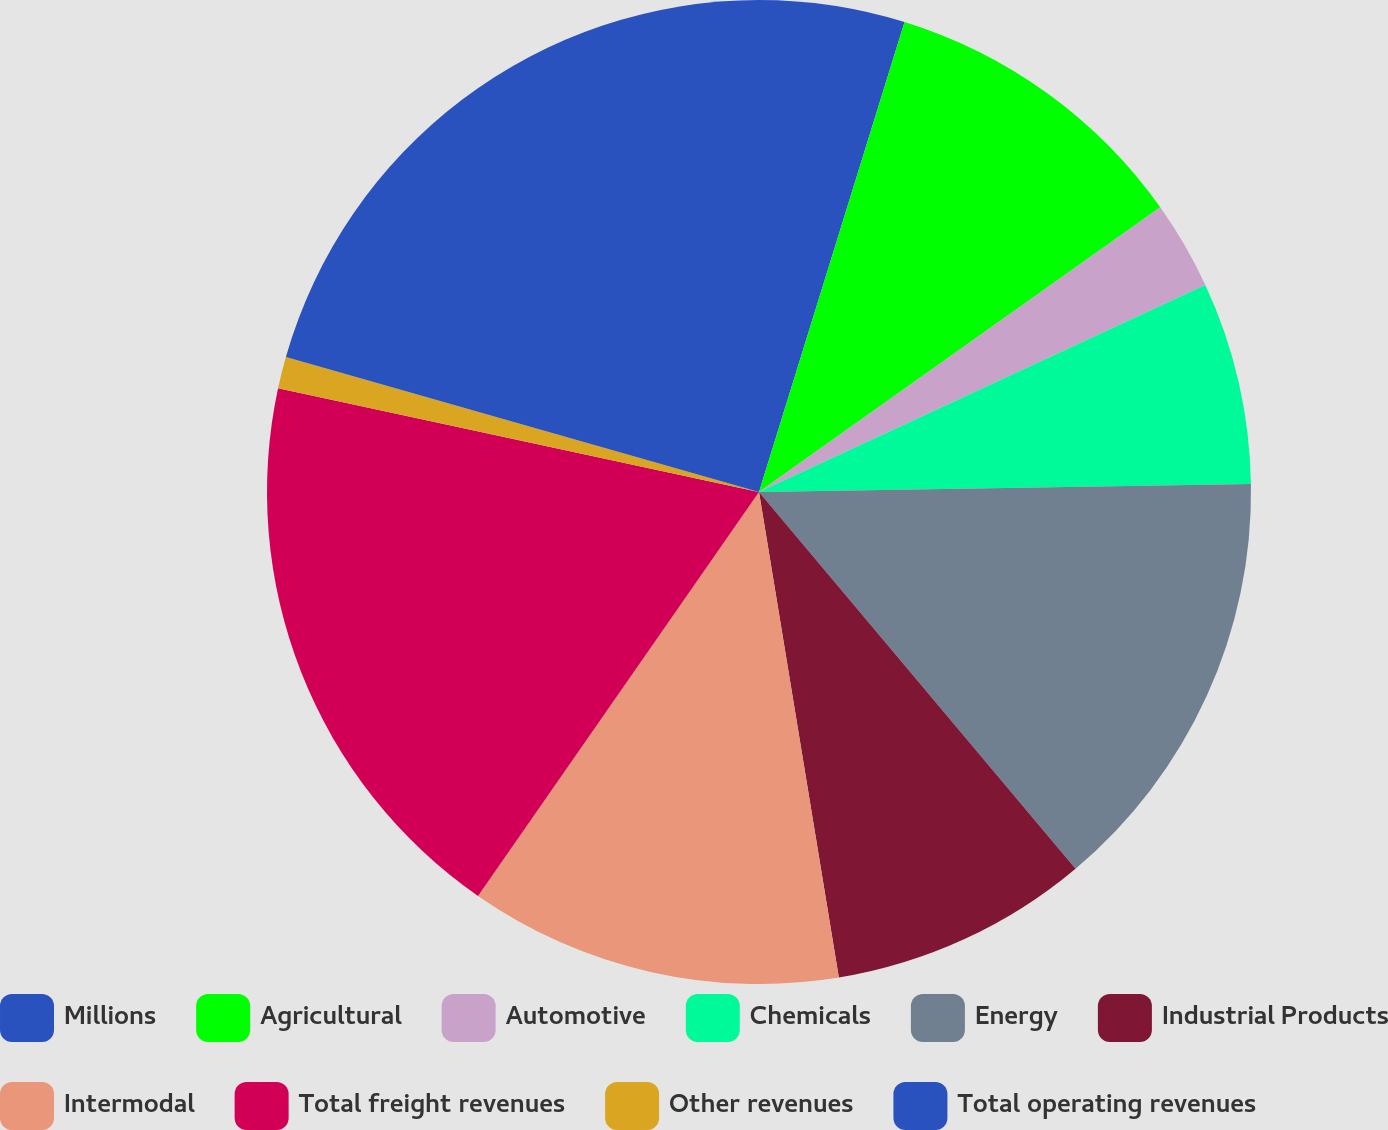Convert chart to OTSL. <chart><loc_0><loc_0><loc_500><loc_500><pie_chart><fcel>Millions<fcel>Agricultural<fcel>Automotive<fcel>Chemicals<fcel>Energy<fcel>Industrial Products<fcel>Intermodal<fcel>Total freight revenues<fcel>Other revenues<fcel>Total operating revenues<nl><fcel>4.78%<fcel>10.4%<fcel>2.91%<fcel>6.65%<fcel>14.14%<fcel>8.53%<fcel>12.27%<fcel>18.71%<fcel>1.04%<fcel>20.58%<nl></chart> 